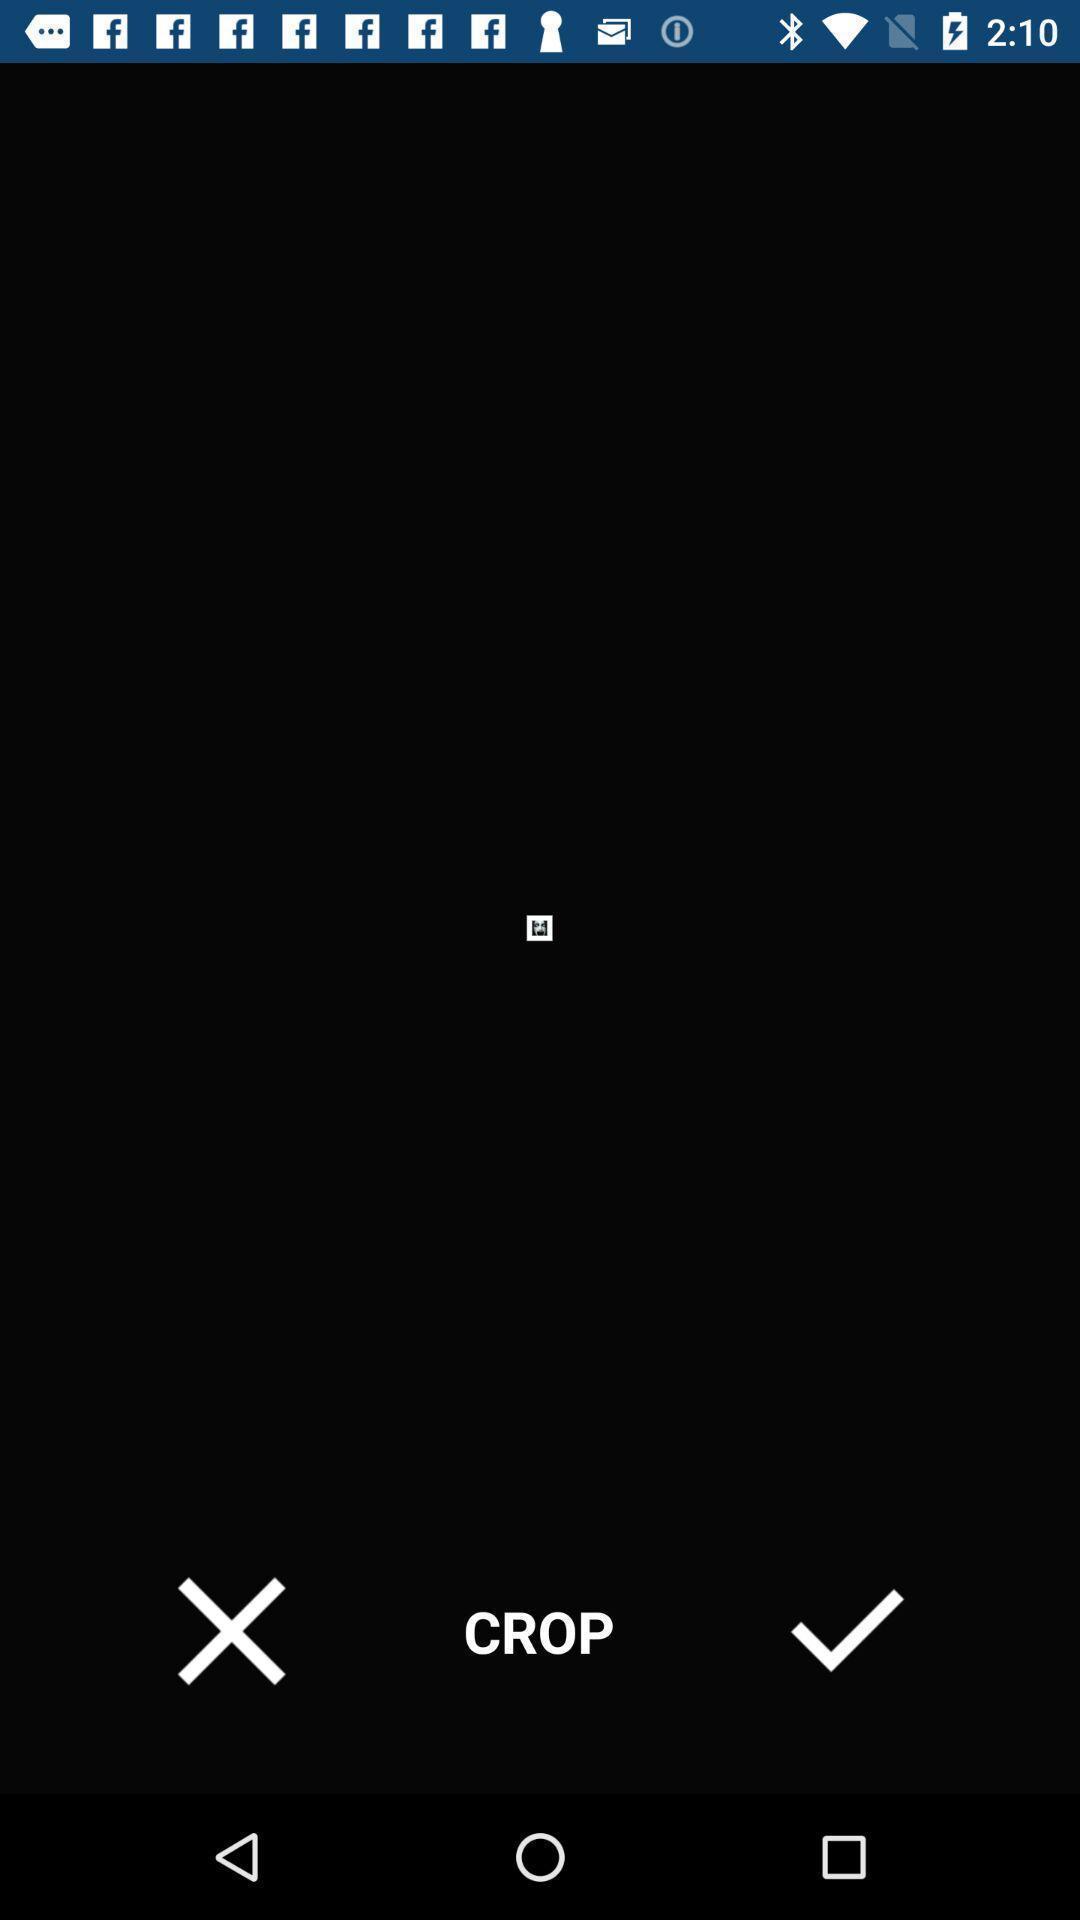Give me a summary of this screen capture. Photo editing page. 